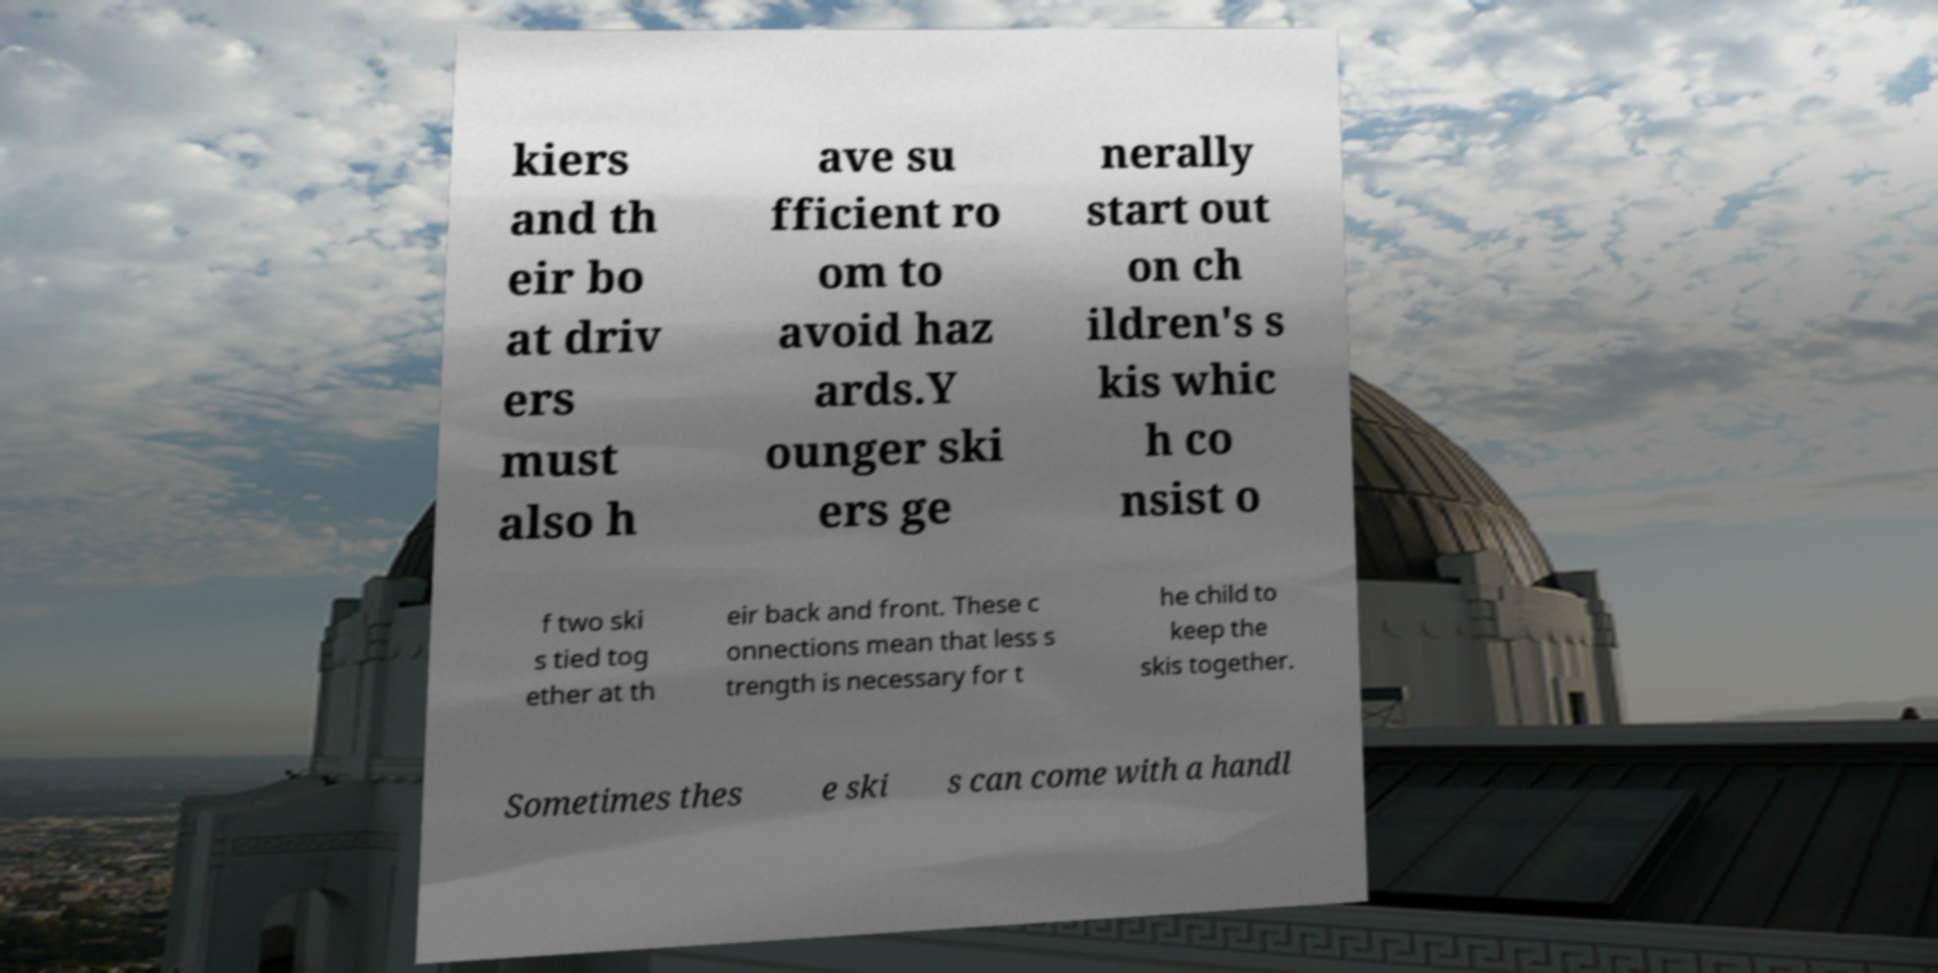Please identify and transcribe the text found in this image. kiers and th eir bo at driv ers must also h ave su fficient ro om to avoid haz ards.Y ounger ski ers ge nerally start out on ch ildren's s kis whic h co nsist o f two ski s tied tog ether at th eir back and front. These c onnections mean that less s trength is necessary for t he child to keep the skis together. Sometimes thes e ski s can come with a handl 